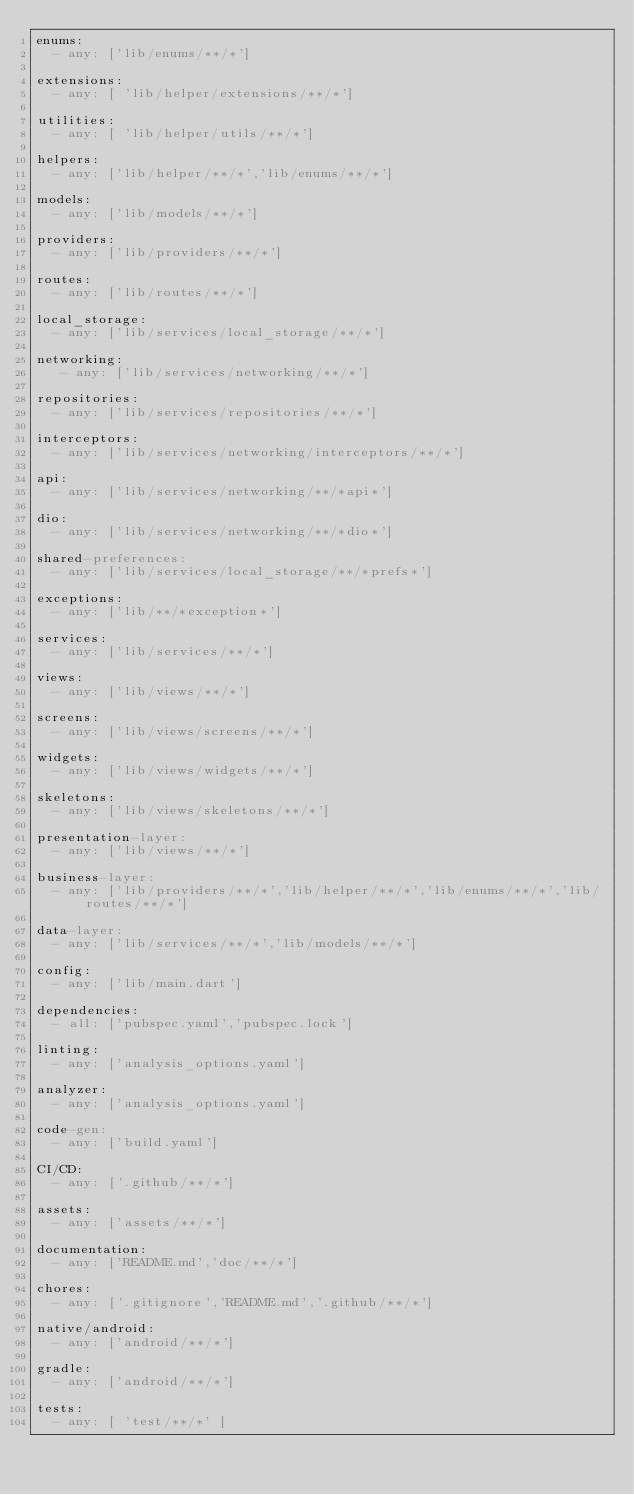Convert code to text. <code><loc_0><loc_0><loc_500><loc_500><_YAML_>enums:
  - any: ['lib/enums/**/*']

extensions:
  - any: [ 'lib/helper/extensions/**/*']

utilities:
  - any: [ 'lib/helper/utils/**/*']

helpers:
  - any: ['lib/helper/**/*','lib/enums/**/*']

models:
  - any: ['lib/models/**/*']

providers:
  - any: ['lib/providers/**/*']

routes:
  - any: ['lib/routes/**/*']

local_storage:
  - any: ['lib/services/local_storage/**/*']

networking:
   - any: ['lib/services/networking/**/*']

repositories:
  - any: ['lib/services/repositories/**/*']

interceptors:
  - any: ['lib/services/networking/interceptors/**/*']

api:
  - any: ['lib/services/networking/**/*api*']

dio:
  - any: ['lib/services/networking/**/*dio*']

shared-preferences:
  - any: ['lib/services/local_storage/**/*prefs*']

exceptions:
  - any: ['lib/**/*exception*']

services:
  - any: ['lib/services/**/*']

views:
  - any: ['lib/views/**/*']

screens:
  - any: ['lib/views/screens/**/*']

widgets:
  - any: ['lib/views/widgets/**/*']

skeletons:
  - any: ['lib/views/skeletons/**/*']

presentation-layer:
  - any: ['lib/views/**/*']

business-layer:
  - any: ['lib/providers/**/*','lib/helper/**/*','lib/enums/**/*','lib/routes/**/*']

data-layer:
  - any: ['lib/services/**/*','lib/models/**/*']

config:
  - any: ['lib/main.dart']

dependencies:
  - all: ['pubspec.yaml','pubspec.lock']

linting:
  - any: ['analysis_options.yaml']

analyzer:
  - any: ['analysis_options.yaml']

code-gen:
  - any: ['build.yaml']

CI/CD:
  - any: ['.github/**/*']

assets:
  - any: ['assets/**/*']

documentation:
  - any: ['README.md','doc/**/*']

chores:
  - any: ['.gitignore','README.md','.github/**/*']

native/android:
  - any: ['android/**/*']

gradle:
  - any: ['android/**/*']

tests:
  - any: [ 'test/**/*' ]</code> 